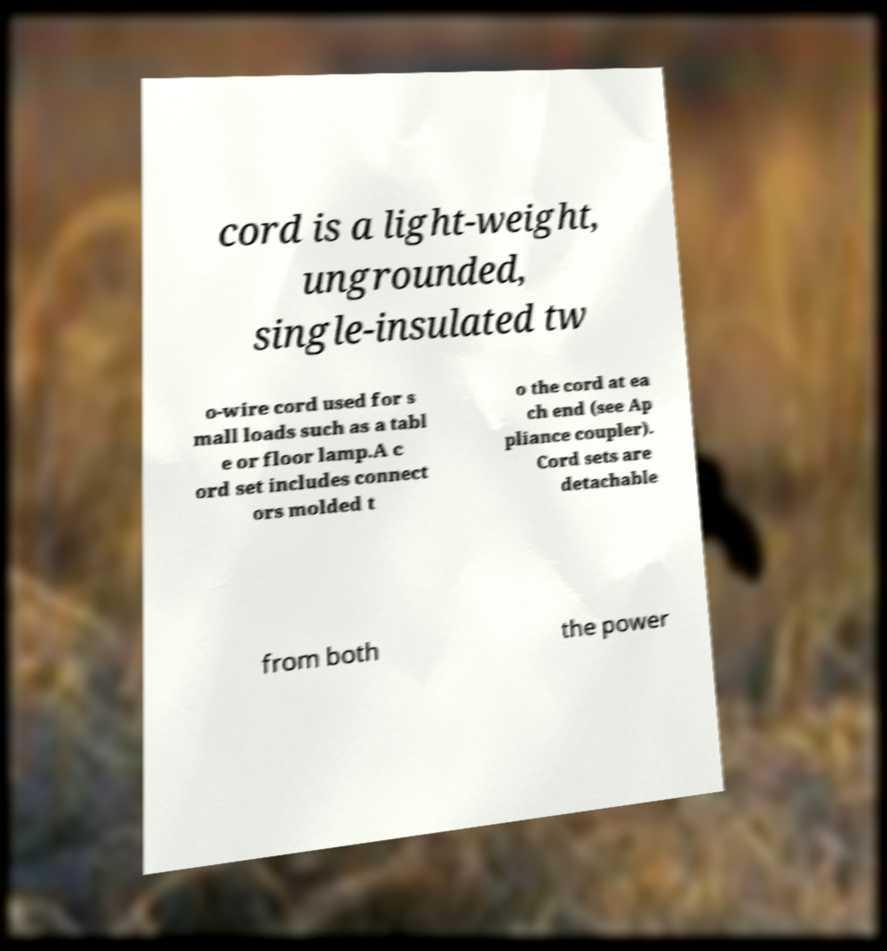Please read and relay the text visible in this image. What does it say? cord is a light-weight, ungrounded, single-insulated tw o-wire cord used for s mall loads such as a tabl e or floor lamp.A c ord set includes connect ors molded t o the cord at ea ch end (see Ap pliance coupler). Cord sets are detachable from both the power 